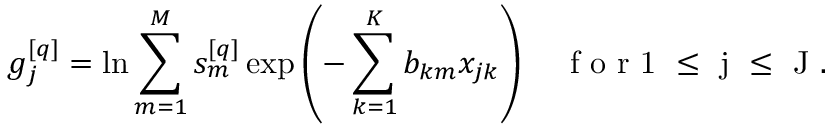Convert formula to latex. <formula><loc_0><loc_0><loc_500><loc_500>g _ { j } ^ { [ q ] } = \ln \sum _ { m = 1 } ^ { M } s _ { m } ^ { [ q ] } \exp \left ( - \sum _ { k = 1 } ^ { K } b _ { k m } x _ { j k } \right ) \quad f o r 1 \leq j \leq J .</formula> 